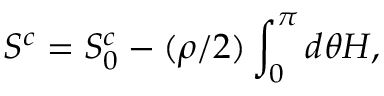<formula> <loc_0><loc_0><loc_500><loc_500>S ^ { c } = S _ { 0 } ^ { c } - ( \rho / 2 ) \int _ { 0 } ^ { \pi } d \theta H ,</formula> 